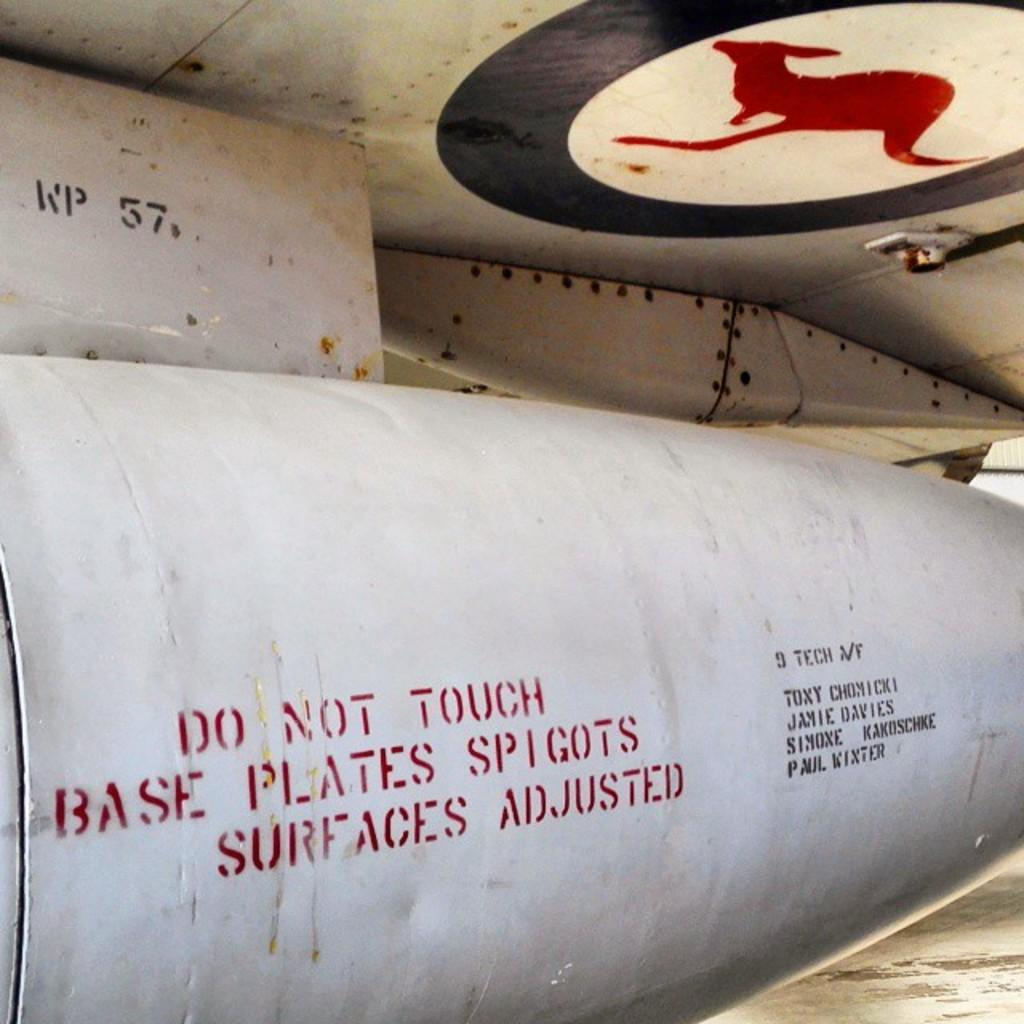<image>
Share a concise interpretation of the image provided. A large silver metal cylindrical object with a stamp on it that says Do Not Touch Base Plates. 